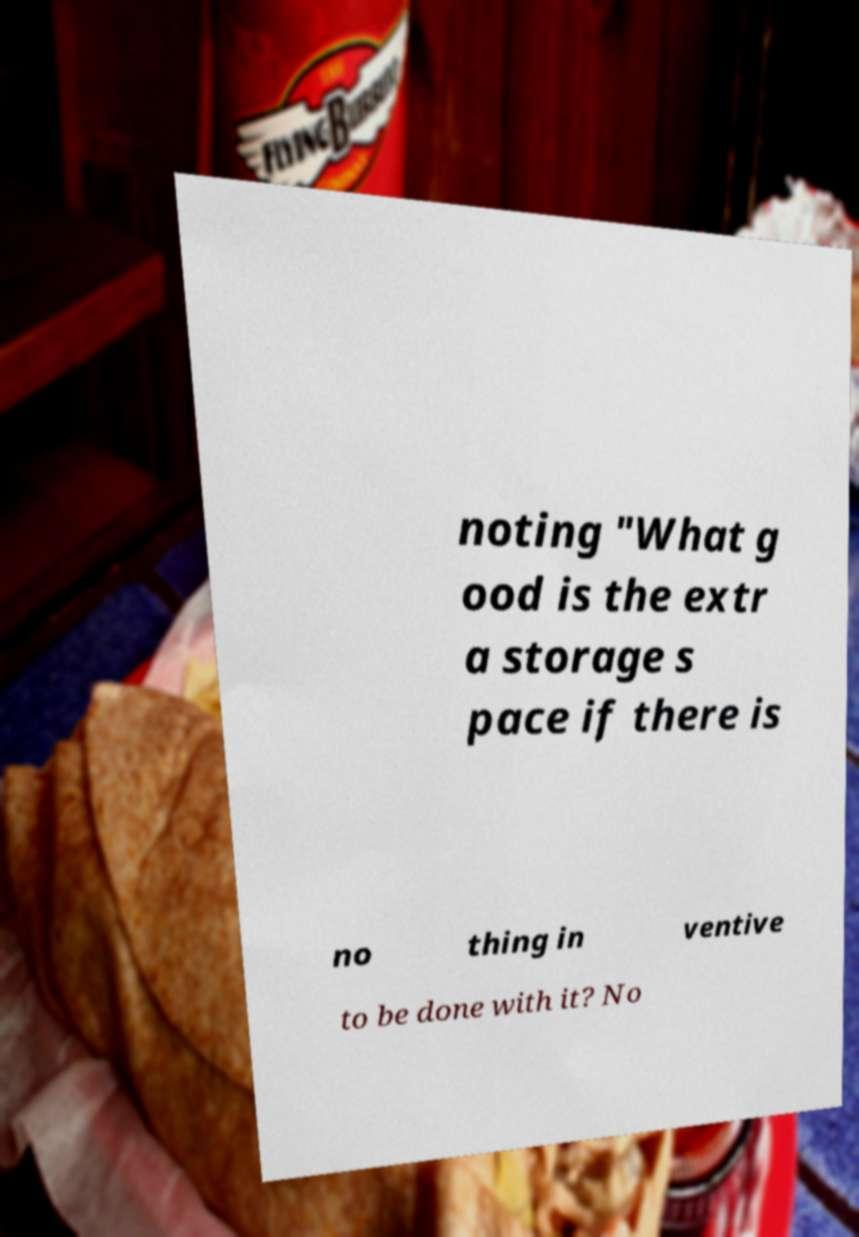What messages or text are displayed in this image? I need them in a readable, typed format. noting "What g ood is the extr a storage s pace if there is no thing in ventive to be done with it? No 